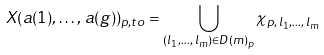<formula> <loc_0><loc_0><loc_500><loc_500>X ( a ( 1 ) , \dots , \, a ( g ) ) _ { p , t o } = \bigcup _ { ( l _ { 1 } , \dots , \, l _ { m } ) \in D ( m ) _ { p } } \chi _ { p , \, l _ { 1 } , \dots , \, l _ { m } }</formula> 